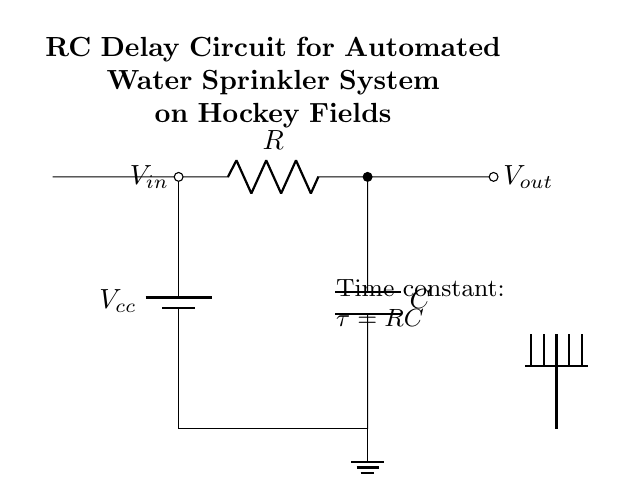What is the voltage input for this circuit? The circuit shows an input labeled as \( V_{in} \) located on the left side, indicating the voltage supplied to the circuit.
Answer: \( V_{in} \) What is the output voltage node labeled as? The output of the circuit is labeled as \( V_{out} \) which is indicated by the short line extending to the right from the circuit.
Answer: \( V_{out} \) What are the components used in this circuit? The circuit consists of a battery (power supply), a resistor, and a capacitor as denoted in the diagram.
Answer: Battery, Resistor, Capacitor What is the time constant equation in this circuit? The time constant is indicated in the diagram with the equation \( \tau = RC \) stated next to the circuit, where \( R \) is the resistance, and \( C \) is the capacitance.
Answer: \( \tau = RC \) What happens to the output voltage when the input voltage is applied? When \( V_{in} \) is applied, the capacitor charges through the resistor, leading to a gradual increase in output voltage until it reaches the input voltage level, causing a delay.
Answer: It charges slowly What type of circuit is represented in this diagram? The circuit is classified as an RC (Resistor-Capacitor) delay circuit, which is used to control the timing of events, such as activating a sprinkler in the automated system.
Answer: RC delay circuit What role does the capacitor play in this circuit? The capacitor stores electrical energy and releases it over time, thereby creating a delay in the output voltage relative to the input when the input voltage is applied.
Answer: Stores energy 